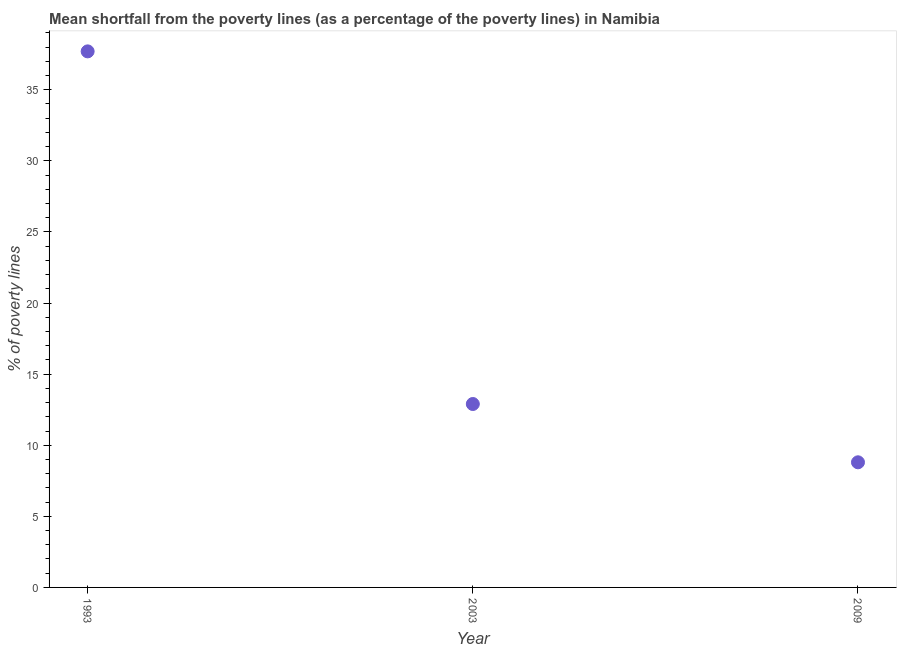What is the poverty gap at national poverty lines in 2009?
Provide a succinct answer. 8.8. Across all years, what is the maximum poverty gap at national poverty lines?
Offer a terse response. 37.7. In which year was the poverty gap at national poverty lines maximum?
Keep it short and to the point. 1993. What is the sum of the poverty gap at national poverty lines?
Keep it short and to the point. 59.4. What is the difference between the poverty gap at national poverty lines in 1993 and 2009?
Keep it short and to the point. 28.9. What is the average poverty gap at national poverty lines per year?
Make the answer very short. 19.8. What is the median poverty gap at national poverty lines?
Offer a very short reply. 12.9. In how many years, is the poverty gap at national poverty lines greater than 34 %?
Your answer should be very brief. 1. Do a majority of the years between 2003 and 1993 (inclusive) have poverty gap at national poverty lines greater than 37 %?
Provide a succinct answer. No. What is the ratio of the poverty gap at national poverty lines in 2003 to that in 2009?
Your answer should be compact. 1.47. What is the difference between the highest and the second highest poverty gap at national poverty lines?
Your answer should be very brief. 24.8. Is the sum of the poverty gap at national poverty lines in 1993 and 2009 greater than the maximum poverty gap at national poverty lines across all years?
Provide a short and direct response. Yes. What is the difference between the highest and the lowest poverty gap at national poverty lines?
Ensure brevity in your answer.  28.9. In how many years, is the poverty gap at national poverty lines greater than the average poverty gap at national poverty lines taken over all years?
Provide a short and direct response. 1. Does the poverty gap at national poverty lines monotonically increase over the years?
Keep it short and to the point. No. How many dotlines are there?
Give a very brief answer. 1. How many years are there in the graph?
Ensure brevity in your answer.  3. Does the graph contain grids?
Your answer should be compact. No. What is the title of the graph?
Provide a short and direct response. Mean shortfall from the poverty lines (as a percentage of the poverty lines) in Namibia. What is the label or title of the X-axis?
Make the answer very short. Year. What is the label or title of the Y-axis?
Offer a very short reply. % of poverty lines. What is the % of poverty lines in 1993?
Provide a succinct answer. 37.7. What is the difference between the % of poverty lines in 1993 and 2003?
Your answer should be very brief. 24.8. What is the difference between the % of poverty lines in 1993 and 2009?
Offer a very short reply. 28.9. What is the difference between the % of poverty lines in 2003 and 2009?
Your answer should be very brief. 4.1. What is the ratio of the % of poverty lines in 1993 to that in 2003?
Ensure brevity in your answer.  2.92. What is the ratio of the % of poverty lines in 1993 to that in 2009?
Give a very brief answer. 4.28. What is the ratio of the % of poverty lines in 2003 to that in 2009?
Offer a very short reply. 1.47. 